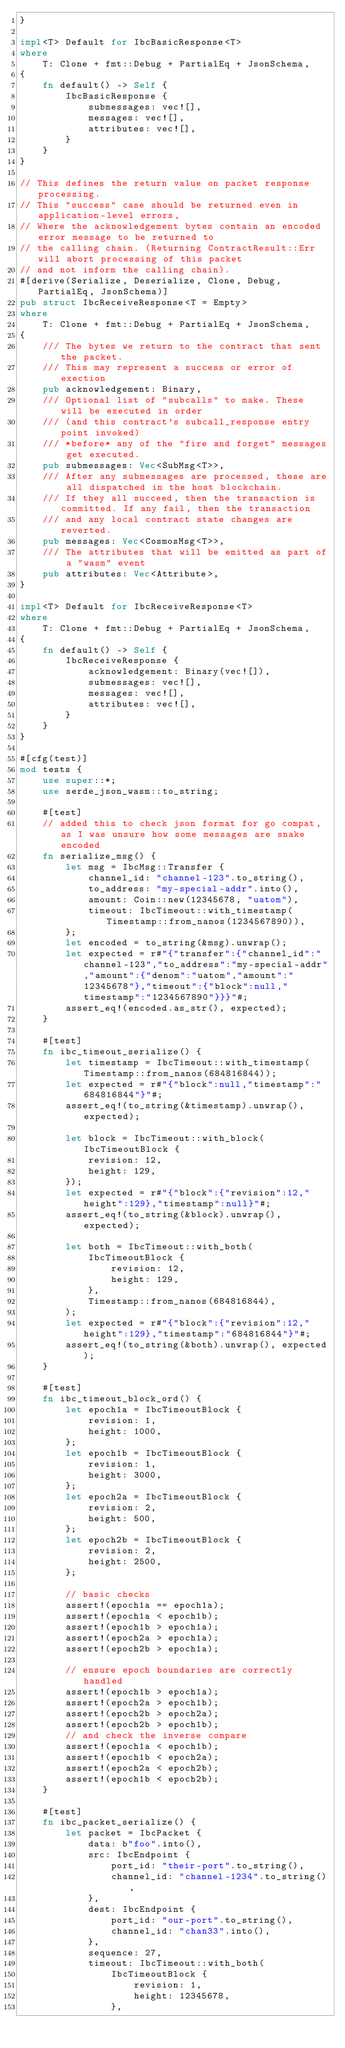Convert code to text. <code><loc_0><loc_0><loc_500><loc_500><_Rust_>}

impl<T> Default for IbcBasicResponse<T>
where
    T: Clone + fmt::Debug + PartialEq + JsonSchema,
{
    fn default() -> Self {
        IbcBasicResponse {
            submessages: vec![],
            messages: vec![],
            attributes: vec![],
        }
    }
}

// This defines the return value on packet response processing.
// This "success" case should be returned even in application-level errors,
// Where the acknowledgement bytes contain an encoded error message to be returned to
// the calling chain. (Returning ContractResult::Err will abort processing of this packet
// and not inform the calling chain).
#[derive(Serialize, Deserialize, Clone, Debug, PartialEq, JsonSchema)]
pub struct IbcReceiveResponse<T = Empty>
where
    T: Clone + fmt::Debug + PartialEq + JsonSchema,
{
    /// The bytes we return to the contract that sent the packet.
    /// This may represent a success or error of exection
    pub acknowledgement: Binary,
    /// Optional list of "subcalls" to make. These will be executed in order
    /// (and this contract's subcall_response entry point invoked)
    /// *before* any of the "fire and forget" messages get executed.
    pub submessages: Vec<SubMsg<T>>,
    /// After any submessages are processed, these are all dispatched in the host blockchain.
    /// If they all succeed, then the transaction is committed. If any fail, then the transaction
    /// and any local contract state changes are reverted.
    pub messages: Vec<CosmosMsg<T>>,
    /// The attributes that will be emitted as part of a "wasm" event
    pub attributes: Vec<Attribute>,
}

impl<T> Default for IbcReceiveResponse<T>
where
    T: Clone + fmt::Debug + PartialEq + JsonSchema,
{
    fn default() -> Self {
        IbcReceiveResponse {
            acknowledgement: Binary(vec![]),
            submessages: vec![],
            messages: vec![],
            attributes: vec![],
        }
    }
}

#[cfg(test)]
mod tests {
    use super::*;
    use serde_json_wasm::to_string;

    #[test]
    // added this to check json format for go compat, as I was unsure how some messages are snake encoded
    fn serialize_msg() {
        let msg = IbcMsg::Transfer {
            channel_id: "channel-123".to_string(),
            to_address: "my-special-addr".into(),
            amount: Coin::new(12345678, "uatom"),
            timeout: IbcTimeout::with_timestamp(Timestamp::from_nanos(1234567890)),
        };
        let encoded = to_string(&msg).unwrap();
        let expected = r#"{"transfer":{"channel_id":"channel-123","to_address":"my-special-addr","amount":{"denom":"uatom","amount":"12345678"},"timeout":{"block":null,"timestamp":"1234567890"}}}"#;
        assert_eq!(encoded.as_str(), expected);
    }

    #[test]
    fn ibc_timeout_serialize() {
        let timestamp = IbcTimeout::with_timestamp(Timestamp::from_nanos(684816844));
        let expected = r#"{"block":null,"timestamp":"684816844"}"#;
        assert_eq!(to_string(&timestamp).unwrap(), expected);

        let block = IbcTimeout::with_block(IbcTimeoutBlock {
            revision: 12,
            height: 129,
        });
        let expected = r#"{"block":{"revision":12,"height":129},"timestamp":null}"#;
        assert_eq!(to_string(&block).unwrap(), expected);

        let both = IbcTimeout::with_both(
            IbcTimeoutBlock {
                revision: 12,
                height: 129,
            },
            Timestamp::from_nanos(684816844),
        );
        let expected = r#"{"block":{"revision":12,"height":129},"timestamp":"684816844"}"#;
        assert_eq!(to_string(&both).unwrap(), expected);
    }

    #[test]
    fn ibc_timeout_block_ord() {
        let epoch1a = IbcTimeoutBlock {
            revision: 1,
            height: 1000,
        };
        let epoch1b = IbcTimeoutBlock {
            revision: 1,
            height: 3000,
        };
        let epoch2a = IbcTimeoutBlock {
            revision: 2,
            height: 500,
        };
        let epoch2b = IbcTimeoutBlock {
            revision: 2,
            height: 2500,
        };

        // basic checks
        assert!(epoch1a == epoch1a);
        assert!(epoch1a < epoch1b);
        assert!(epoch1b > epoch1a);
        assert!(epoch2a > epoch1a);
        assert!(epoch2b > epoch1a);

        // ensure epoch boundaries are correctly handled
        assert!(epoch1b > epoch1a);
        assert!(epoch2a > epoch1b);
        assert!(epoch2b > epoch2a);
        assert!(epoch2b > epoch1b);
        // and check the inverse compare
        assert!(epoch1a < epoch1b);
        assert!(epoch1b < epoch2a);
        assert!(epoch2a < epoch2b);
        assert!(epoch1b < epoch2b);
    }

    #[test]
    fn ibc_packet_serialize() {
        let packet = IbcPacket {
            data: b"foo".into(),
            src: IbcEndpoint {
                port_id: "their-port".to_string(),
                channel_id: "channel-1234".to_string(),
            },
            dest: IbcEndpoint {
                port_id: "our-port".to_string(),
                channel_id: "chan33".into(),
            },
            sequence: 27,
            timeout: IbcTimeout::with_both(
                IbcTimeoutBlock {
                    revision: 1,
                    height: 12345678,
                },</code> 